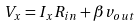<formula> <loc_0><loc_0><loc_500><loc_500>V _ { x } = I _ { x } R _ { i n } + \beta v _ { o u t }</formula> 